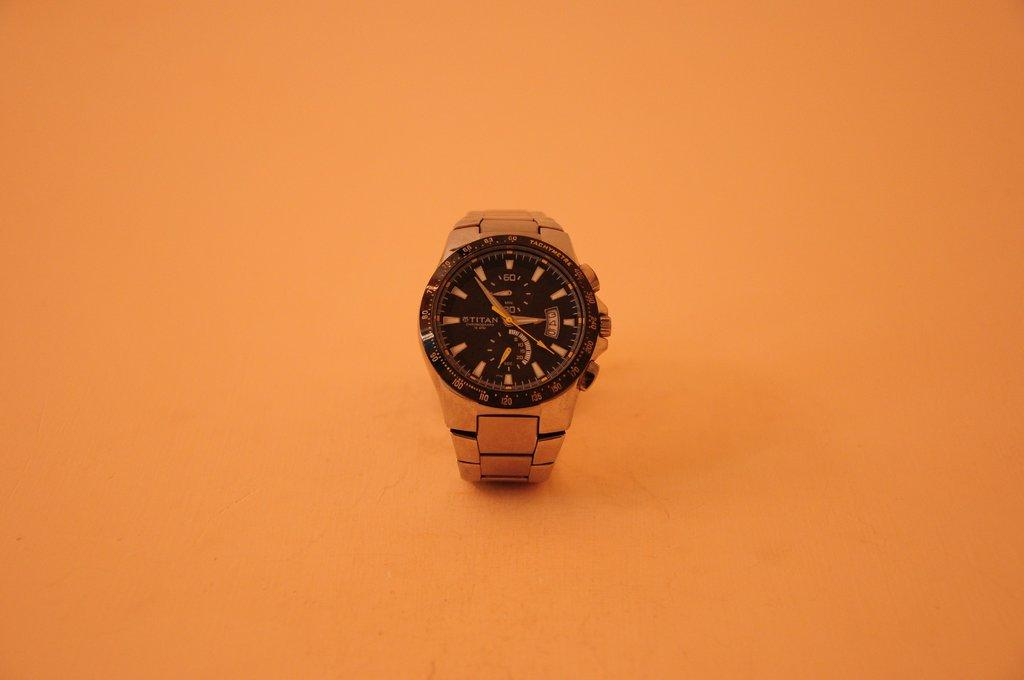<image>
Give a short and clear explanation of the subsequent image. A Titan chronograph watch sits on an orange table. 